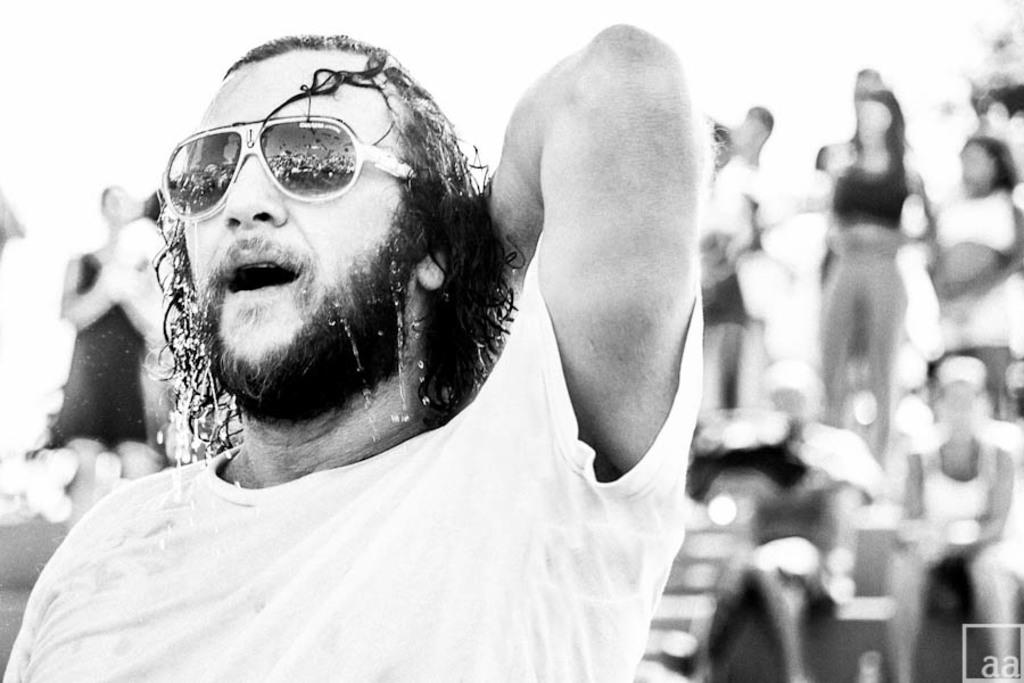What is on the left side of the image? There is a person on the left side of the image. Can you describe the person's appearance? The person is wearing glasses (spec). What is on the right side of the image? There are people on the right side of the image. What type of spade is being used by the person on the left side of the image? There is no spade present in the image; the person is wearing glasses. What role does the judge play in the image? There is no judge present in the image. 